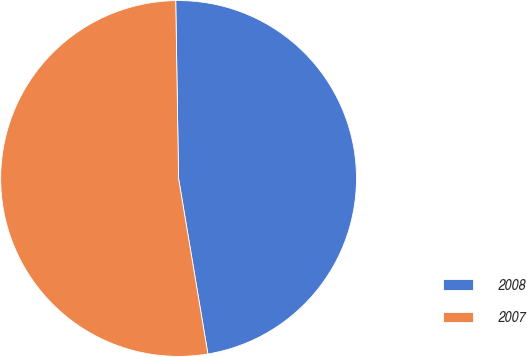Convert chart. <chart><loc_0><loc_0><loc_500><loc_500><pie_chart><fcel>2008<fcel>2007<nl><fcel>47.62%<fcel>52.38%<nl></chart> 